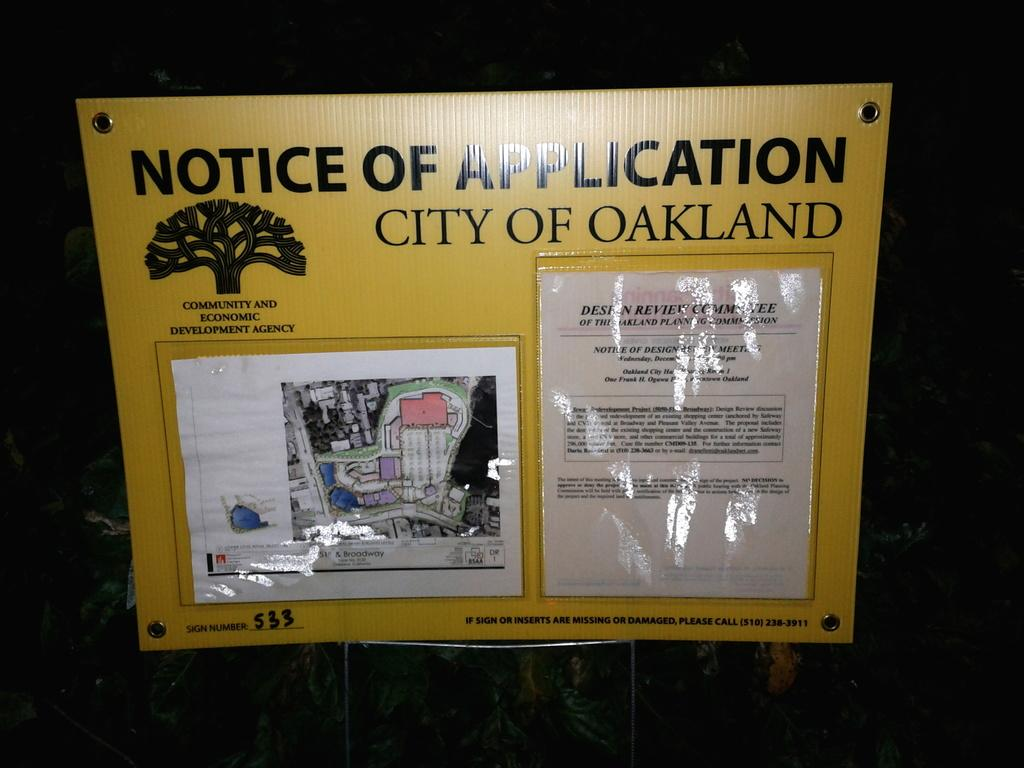<image>
Offer a succinct explanation of the picture presented. A sign for the city of Oakland displays the notice of application. 